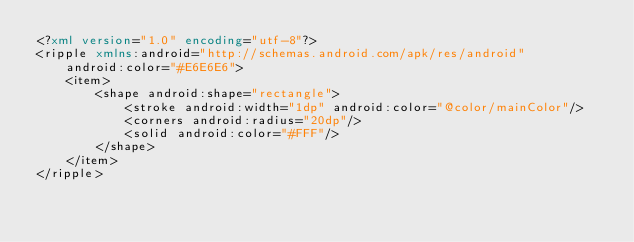<code> <loc_0><loc_0><loc_500><loc_500><_XML_><?xml version="1.0" encoding="utf-8"?>
<ripple xmlns:android="http://schemas.android.com/apk/res/android"
    android:color="#E6E6E6">
    <item>
        <shape android:shape="rectangle">
            <stroke android:width="1dp" android:color="@color/mainColor"/>
            <corners android:radius="20dp"/>
            <solid android:color="#FFF"/>
        </shape>
    </item>
</ripple></code> 